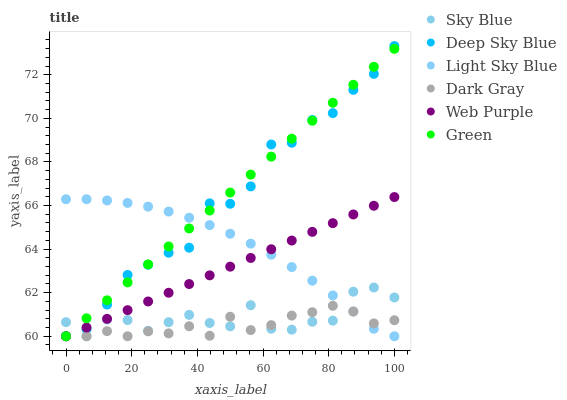Does Dark Gray have the minimum area under the curve?
Answer yes or no. Yes. Does Green have the maximum area under the curve?
Answer yes or no. Yes. Does Web Purple have the minimum area under the curve?
Answer yes or no. No. Does Web Purple have the maximum area under the curve?
Answer yes or no. No. Is Web Purple the smoothest?
Answer yes or no. Yes. Is Deep Sky Blue the roughest?
Answer yes or no. Yes. Is Light Sky Blue the smoothest?
Answer yes or no. No. Is Light Sky Blue the roughest?
Answer yes or no. No. Does Dark Gray have the lowest value?
Answer yes or no. Yes. Does Deep Sky Blue have the highest value?
Answer yes or no. Yes. Does Web Purple have the highest value?
Answer yes or no. No. Does Green intersect Light Sky Blue?
Answer yes or no. Yes. Is Green less than Light Sky Blue?
Answer yes or no. No. Is Green greater than Light Sky Blue?
Answer yes or no. No. 